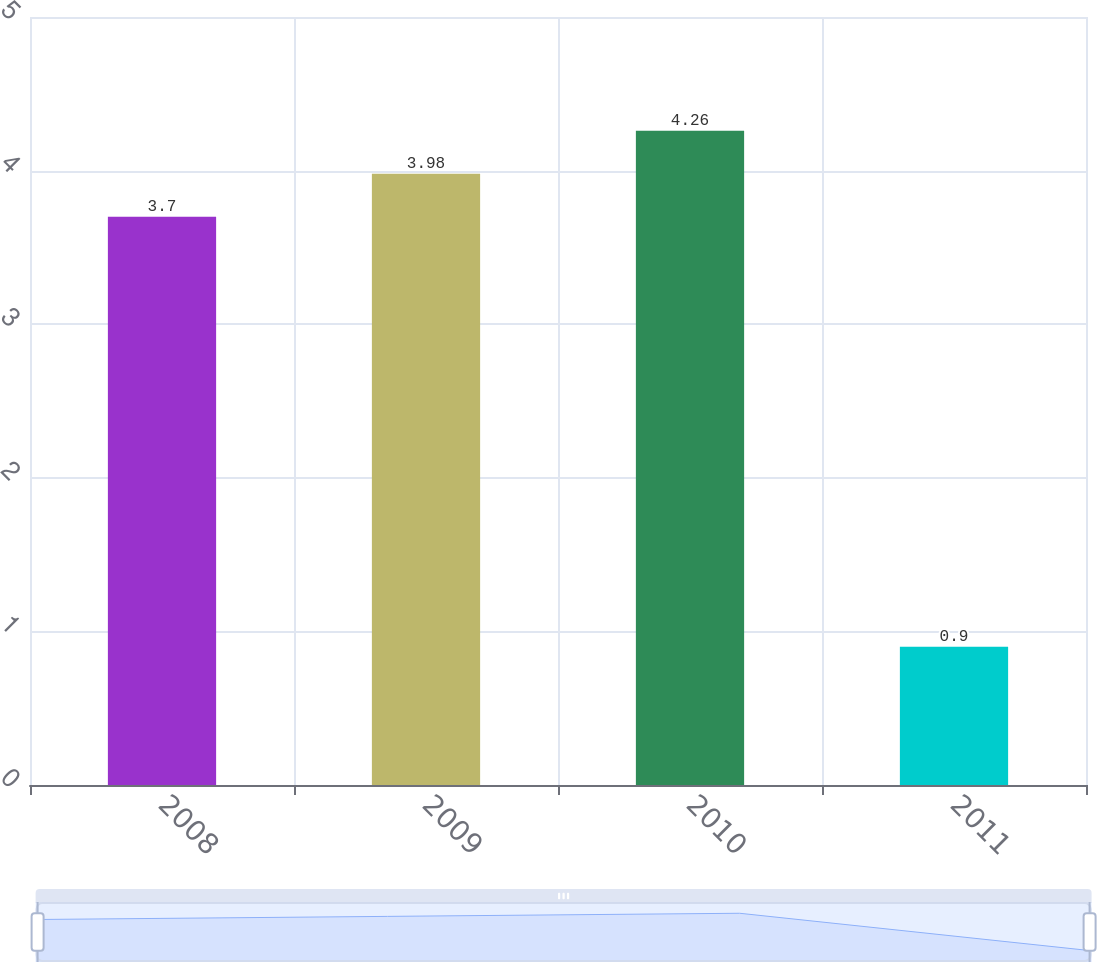Convert chart. <chart><loc_0><loc_0><loc_500><loc_500><bar_chart><fcel>2008<fcel>2009<fcel>2010<fcel>2011<nl><fcel>3.7<fcel>3.98<fcel>4.26<fcel>0.9<nl></chart> 